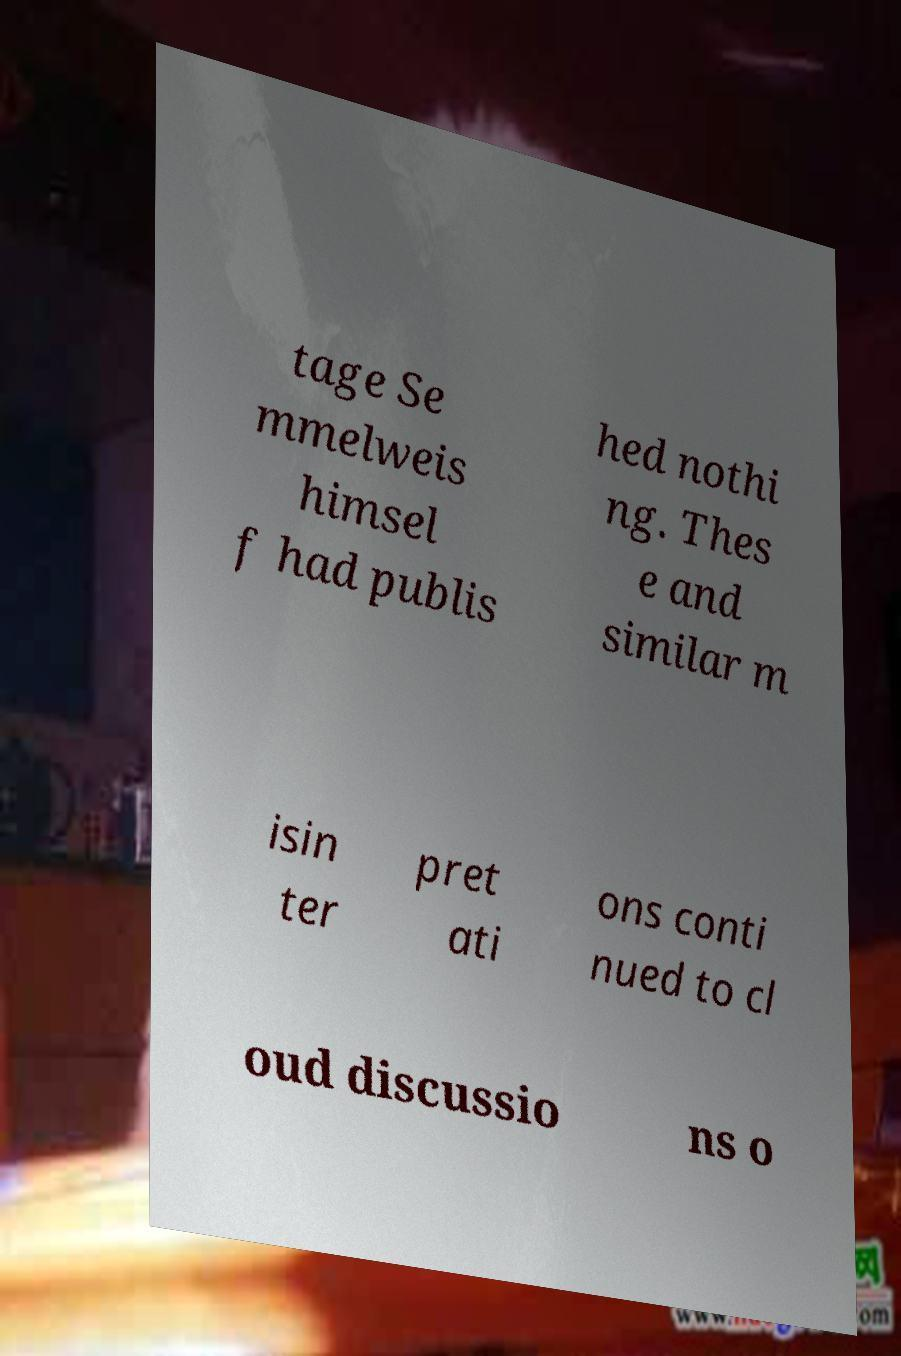Please identify and transcribe the text found in this image. tage Se mmelweis himsel f had publis hed nothi ng. Thes e and similar m isin ter pret ati ons conti nued to cl oud discussio ns o 